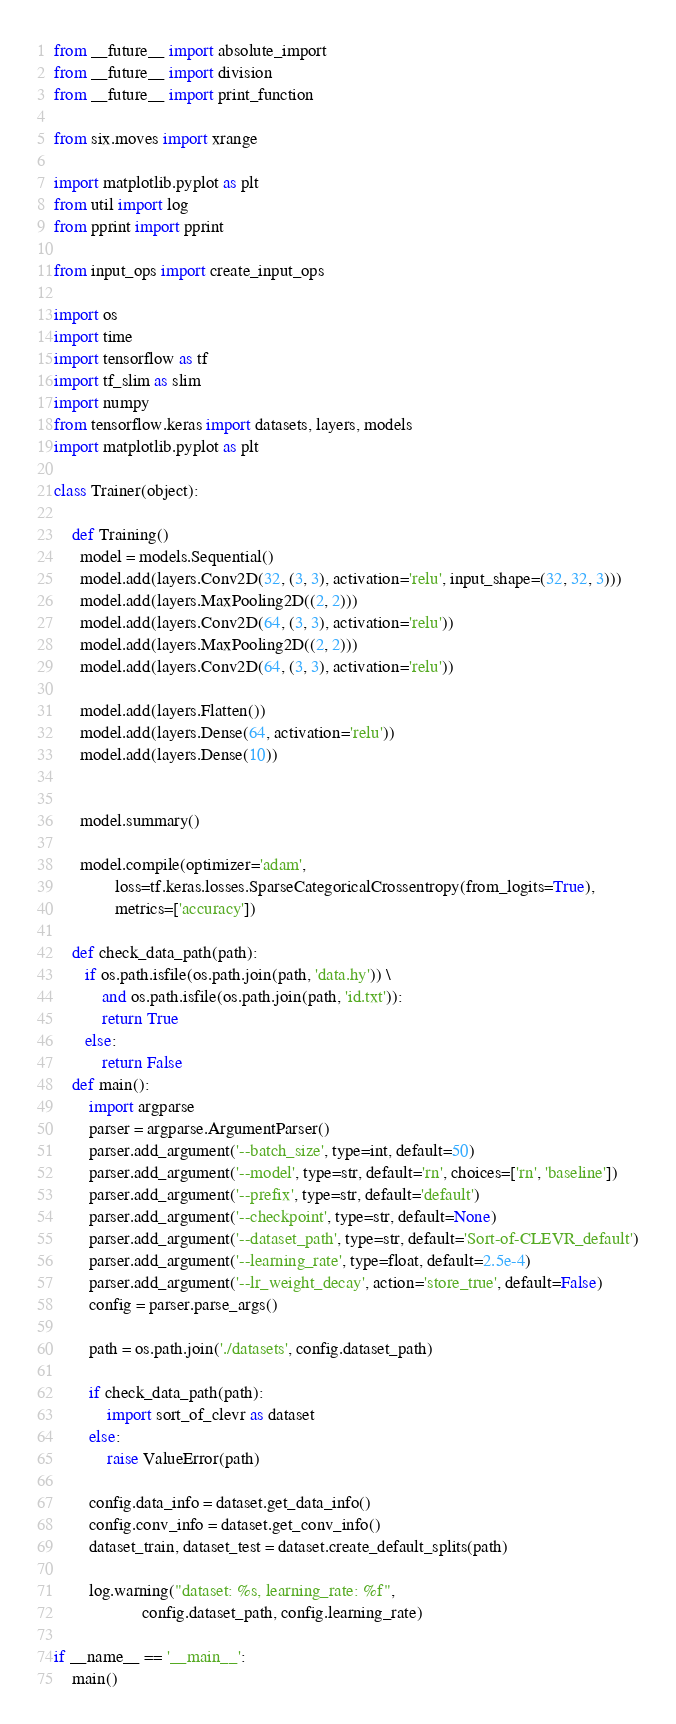Convert code to text. <code><loc_0><loc_0><loc_500><loc_500><_Python_>
from __future__ import absolute_import
from __future__ import division
from __future__ import print_function

from six.moves import xrange

import matplotlib.pyplot as plt
from util import log
from pprint import pprint

from input_ops import create_input_ops

import os
import time
import tensorflow as tf
import tf_slim as slim
import numpy
from tensorflow.keras import datasets, layers, models
import matplotlib.pyplot as plt

class Trainer(object):

    def Training()
      model = models.Sequential()
      model.add(layers.Conv2D(32, (3, 3), activation='relu', input_shape=(32, 32, 3)))
      model.add(layers.MaxPooling2D((2, 2)))
      model.add(layers.Conv2D(64, (3, 3), activation='relu'))
      model.add(layers.MaxPooling2D((2, 2)))
      model.add(layers.Conv2D(64, (3, 3), activation='relu'))

      model.add(layers.Flatten())
      model.add(layers.Dense(64, activation='relu'))
      model.add(layers.Dense(10))


      model.summary()

      model.compile(optimizer='adam',
              loss=tf.keras.losses.SparseCategoricalCrossentropy(from_logits=True),
              metrics=['accuracy'])

    def check_data_path(path):
       if os.path.isfile(os.path.join(path, 'data.hy')) \
           and os.path.isfile(os.path.join(path, 'id.txt')):
           return True
       else:
           return False
    def main():
        import argparse
        parser = argparse.ArgumentParser()
        parser.add_argument('--batch_size', type=int, default=50)
        parser.add_argument('--model', type=str, default='rn', choices=['rn', 'baseline'])
        parser.add_argument('--prefix', type=str, default='default')
        parser.add_argument('--checkpoint', type=str, default=None)
        parser.add_argument('--dataset_path', type=str, default='Sort-of-CLEVR_default')
        parser.add_argument('--learning_rate', type=float, default=2.5e-4)
        parser.add_argument('--lr_weight_decay', action='store_true', default=False)
        config = parser.parse_args()

        path = os.path.join('./datasets', config.dataset_path)

        if check_data_path(path):
            import sort_of_clevr as dataset
        else:
            raise ValueError(path)

        config.data_info = dataset.get_data_info()
        config.conv_info = dataset.get_conv_info()
        dataset_train, dataset_test = dataset.create_default_splits(path)

        log.warning("dataset: %s, learning_rate: %f",
                    config.dataset_path, config.learning_rate)
        
if __name__ == '__main__':
    main()
</code> 